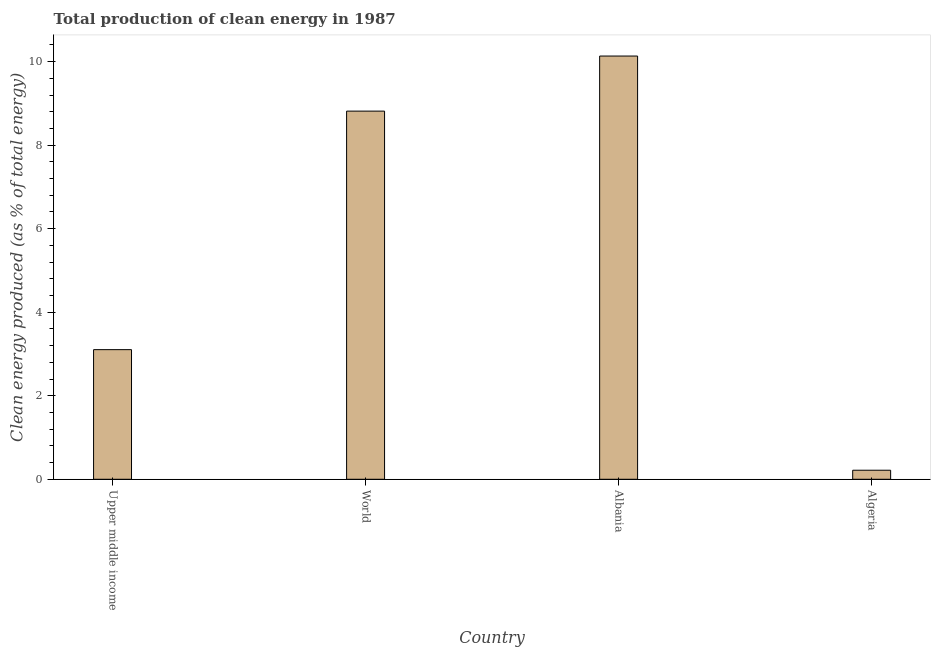Does the graph contain grids?
Give a very brief answer. No. What is the title of the graph?
Your answer should be very brief. Total production of clean energy in 1987. What is the label or title of the Y-axis?
Offer a very short reply. Clean energy produced (as % of total energy). What is the production of clean energy in Algeria?
Provide a succinct answer. 0.22. Across all countries, what is the maximum production of clean energy?
Your answer should be very brief. 10.13. Across all countries, what is the minimum production of clean energy?
Your response must be concise. 0.22. In which country was the production of clean energy maximum?
Your answer should be very brief. Albania. In which country was the production of clean energy minimum?
Provide a short and direct response. Algeria. What is the sum of the production of clean energy?
Your response must be concise. 22.27. What is the difference between the production of clean energy in Algeria and Upper middle income?
Provide a short and direct response. -2.89. What is the average production of clean energy per country?
Your answer should be very brief. 5.57. What is the median production of clean energy?
Keep it short and to the point. 5.96. In how many countries, is the production of clean energy greater than 9.2 %?
Offer a terse response. 1. What is the ratio of the production of clean energy in Algeria to that in World?
Your answer should be very brief. 0.03. Is the production of clean energy in Algeria less than that in Upper middle income?
Ensure brevity in your answer.  Yes. What is the difference between the highest and the second highest production of clean energy?
Provide a short and direct response. 1.32. What is the difference between the highest and the lowest production of clean energy?
Provide a succinct answer. 9.92. Are all the bars in the graph horizontal?
Make the answer very short. No. How many countries are there in the graph?
Give a very brief answer. 4. What is the difference between two consecutive major ticks on the Y-axis?
Make the answer very short. 2. Are the values on the major ticks of Y-axis written in scientific E-notation?
Provide a succinct answer. No. What is the Clean energy produced (as % of total energy) of Upper middle income?
Provide a short and direct response. 3.1. What is the Clean energy produced (as % of total energy) in World?
Keep it short and to the point. 8.82. What is the Clean energy produced (as % of total energy) of Albania?
Provide a short and direct response. 10.13. What is the Clean energy produced (as % of total energy) of Algeria?
Your answer should be compact. 0.22. What is the difference between the Clean energy produced (as % of total energy) in Upper middle income and World?
Offer a very short reply. -5.71. What is the difference between the Clean energy produced (as % of total energy) in Upper middle income and Albania?
Offer a terse response. -7.03. What is the difference between the Clean energy produced (as % of total energy) in Upper middle income and Algeria?
Provide a succinct answer. 2.89. What is the difference between the Clean energy produced (as % of total energy) in World and Albania?
Your answer should be very brief. -1.32. What is the difference between the Clean energy produced (as % of total energy) in World and Algeria?
Your answer should be very brief. 8.6. What is the difference between the Clean energy produced (as % of total energy) in Albania and Algeria?
Keep it short and to the point. 9.92. What is the ratio of the Clean energy produced (as % of total energy) in Upper middle income to that in World?
Keep it short and to the point. 0.35. What is the ratio of the Clean energy produced (as % of total energy) in Upper middle income to that in Albania?
Provide a short and direct response. 0.31. What is the ratio of the Clean energy produced (as % of total energy) in Upper middle income to that in Algeria?
Your answer should be compact. 14.32. What is the ratio of the Clean energy produced (as % of total energy) in World to that in Albania?
Give a very brief answer. 0.87. What is the ratio of the Clean energy produced (as % of total energy) in World to that in Algeria?
Provide a short and direct response. 40.66. What is the ratio of the Clean energy produced (as % of total energy) in Albania to that in Algeria?
Keep it short and to the point. 46.74. 